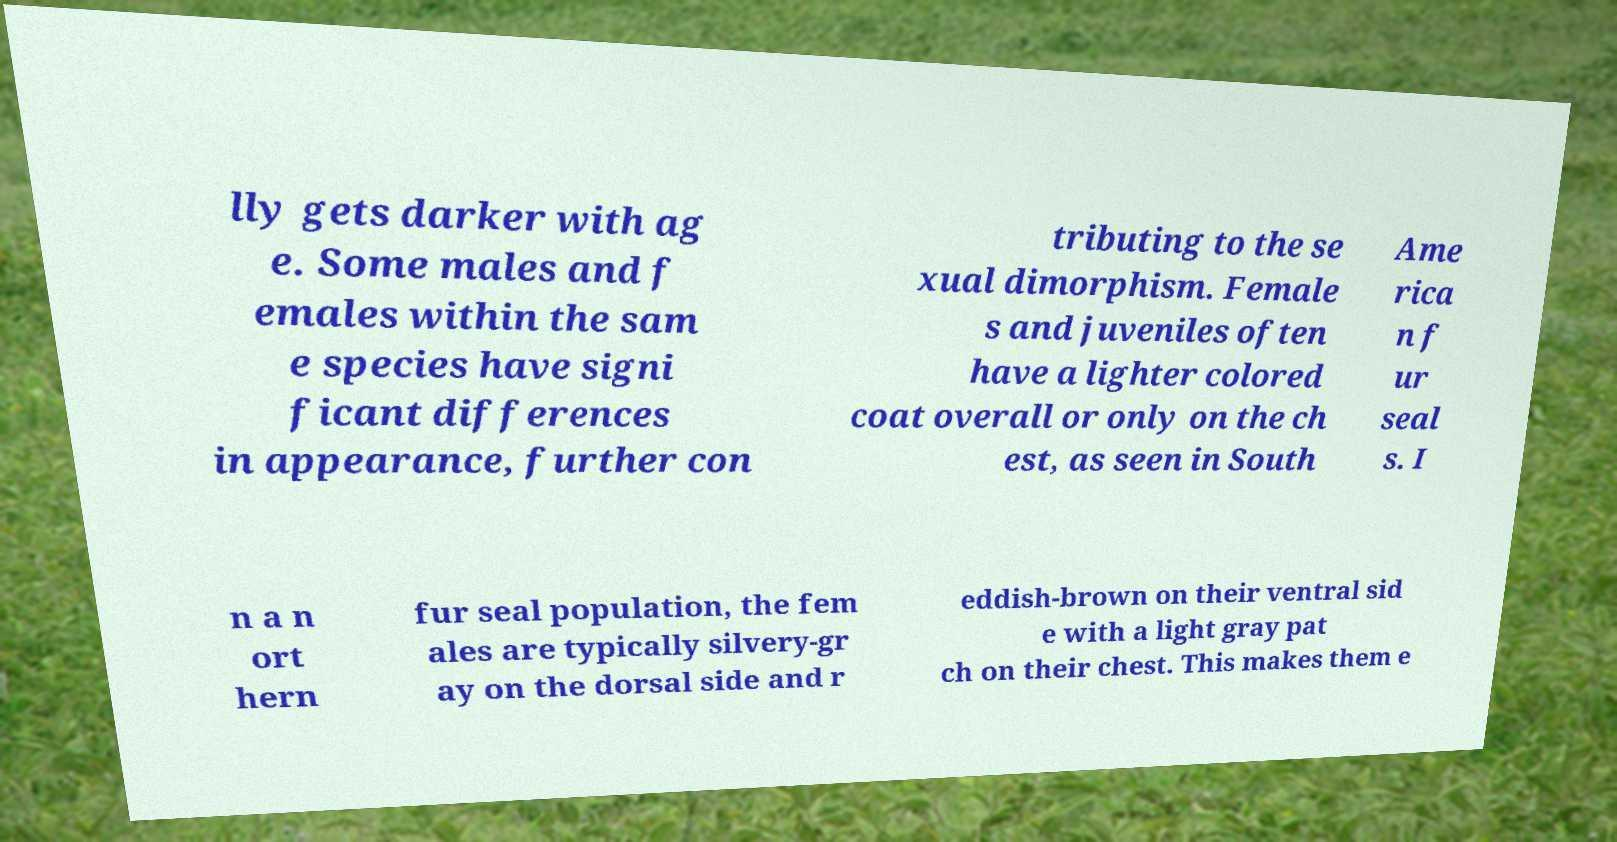Please identify and transcribe the text found in this image. lly gets darker with ag e. Some males and f emales within the sam e species have signi ficant differences in appearance, further con tributing to the se xual dimorphism. Female s and juveniles often have a lighter colored coat overall or only on the ch est, as seen in South Ame rica n f ur seal s. I n a n ort hern fur seal population, the fem ales are typically silvery-gr ay on the dorsal side and r eddish-brown on their ventral sid e with a light gray pat ch on their chest. This makes them e 